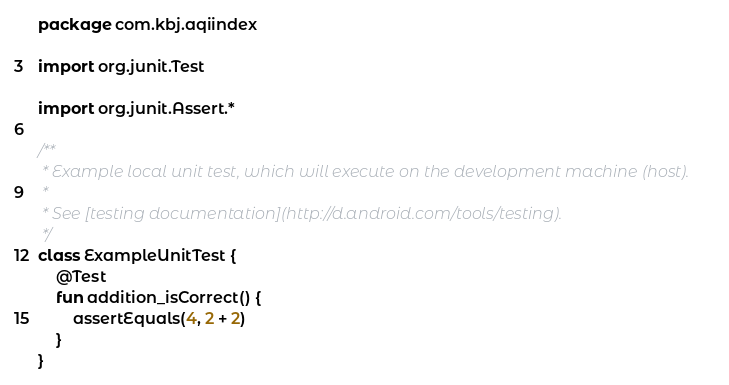<code> <loc_0><loc_0><loc_500><loc_500><_Kotlin_>package com.kbj.aqiindex

import org.junit.Test

import org.junit.Assert.*

/**
 * Example local unit test, which will execute on the development machine (host).
 *
 * See [testing documentation](http://d.android.com/tools/testing).
 */
class ExampleUnitTest {
    @Test
    fun addition_isCorrect() {
        assertEquals(4, 2 + 2)
    }
}</code> 